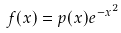<formula> <loc_0><loc_0><loc_500><loc_500>f ( x ) = p ( x ) e ^ { - x ^ { 2 } }</formula> 